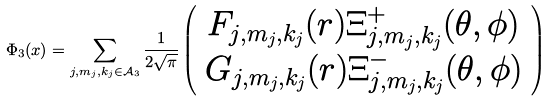Convert formula to latex. <formula><loc_0><loc_0><loc_500><loc_500>\Phi _ { 3 } ( x ) = \sum _ { j , m _ { j } , k _ { j } \in \mathcal { A } _ { 3 } } \frac { 1 } { 2 \sqrt { \pi } } \left ( \begin{array} { c c } F _ { j , m _ { j } , k _ { j } } ( r ) \Xi ^ { + } _ { j , m _ { j } , k _ { j } } ( \theta , \phi ) \\ G _ { j , m _ { j } , k _ { j } } ( r ) \Xi ^ { - } _ { j , m _ { j } , k _ { j } } ( \theta , \phi ) \end{array} \right )</formula> 